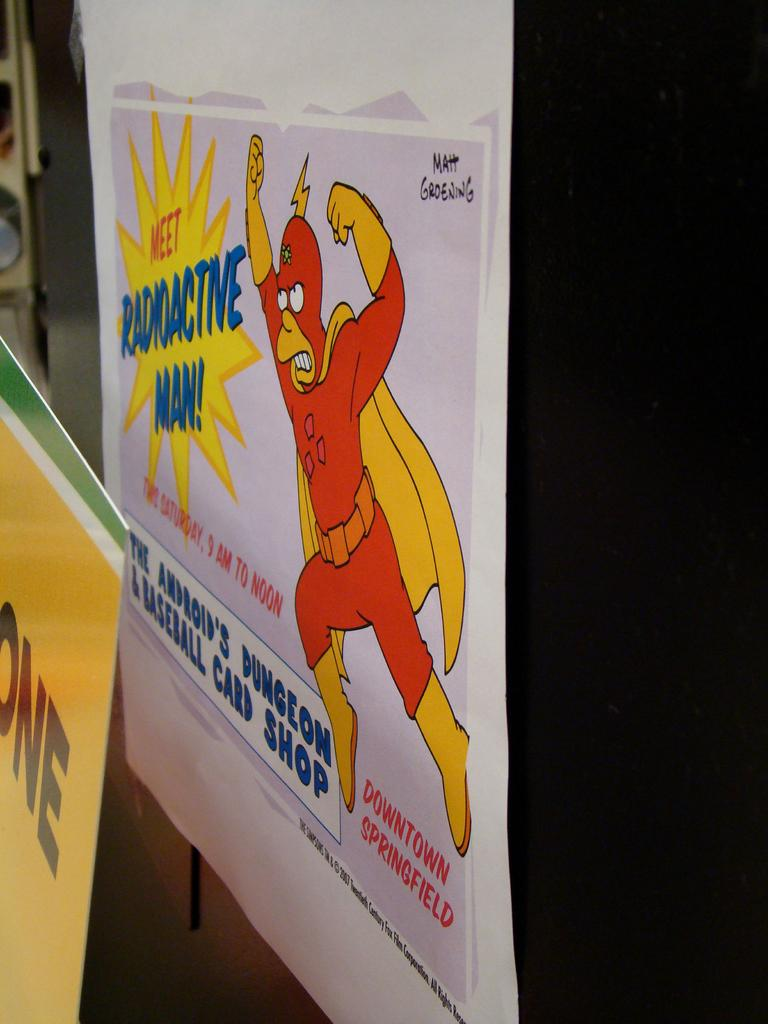<image>
Offer a succinct explanation of the picture presented. A poster with a picture of a man in a suit is titled Meet Radioactive Man! 